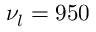<formula> <loc_0><loc_0><loc_500><loc_500>\nu _ { l } = 9 5 0</formula> 